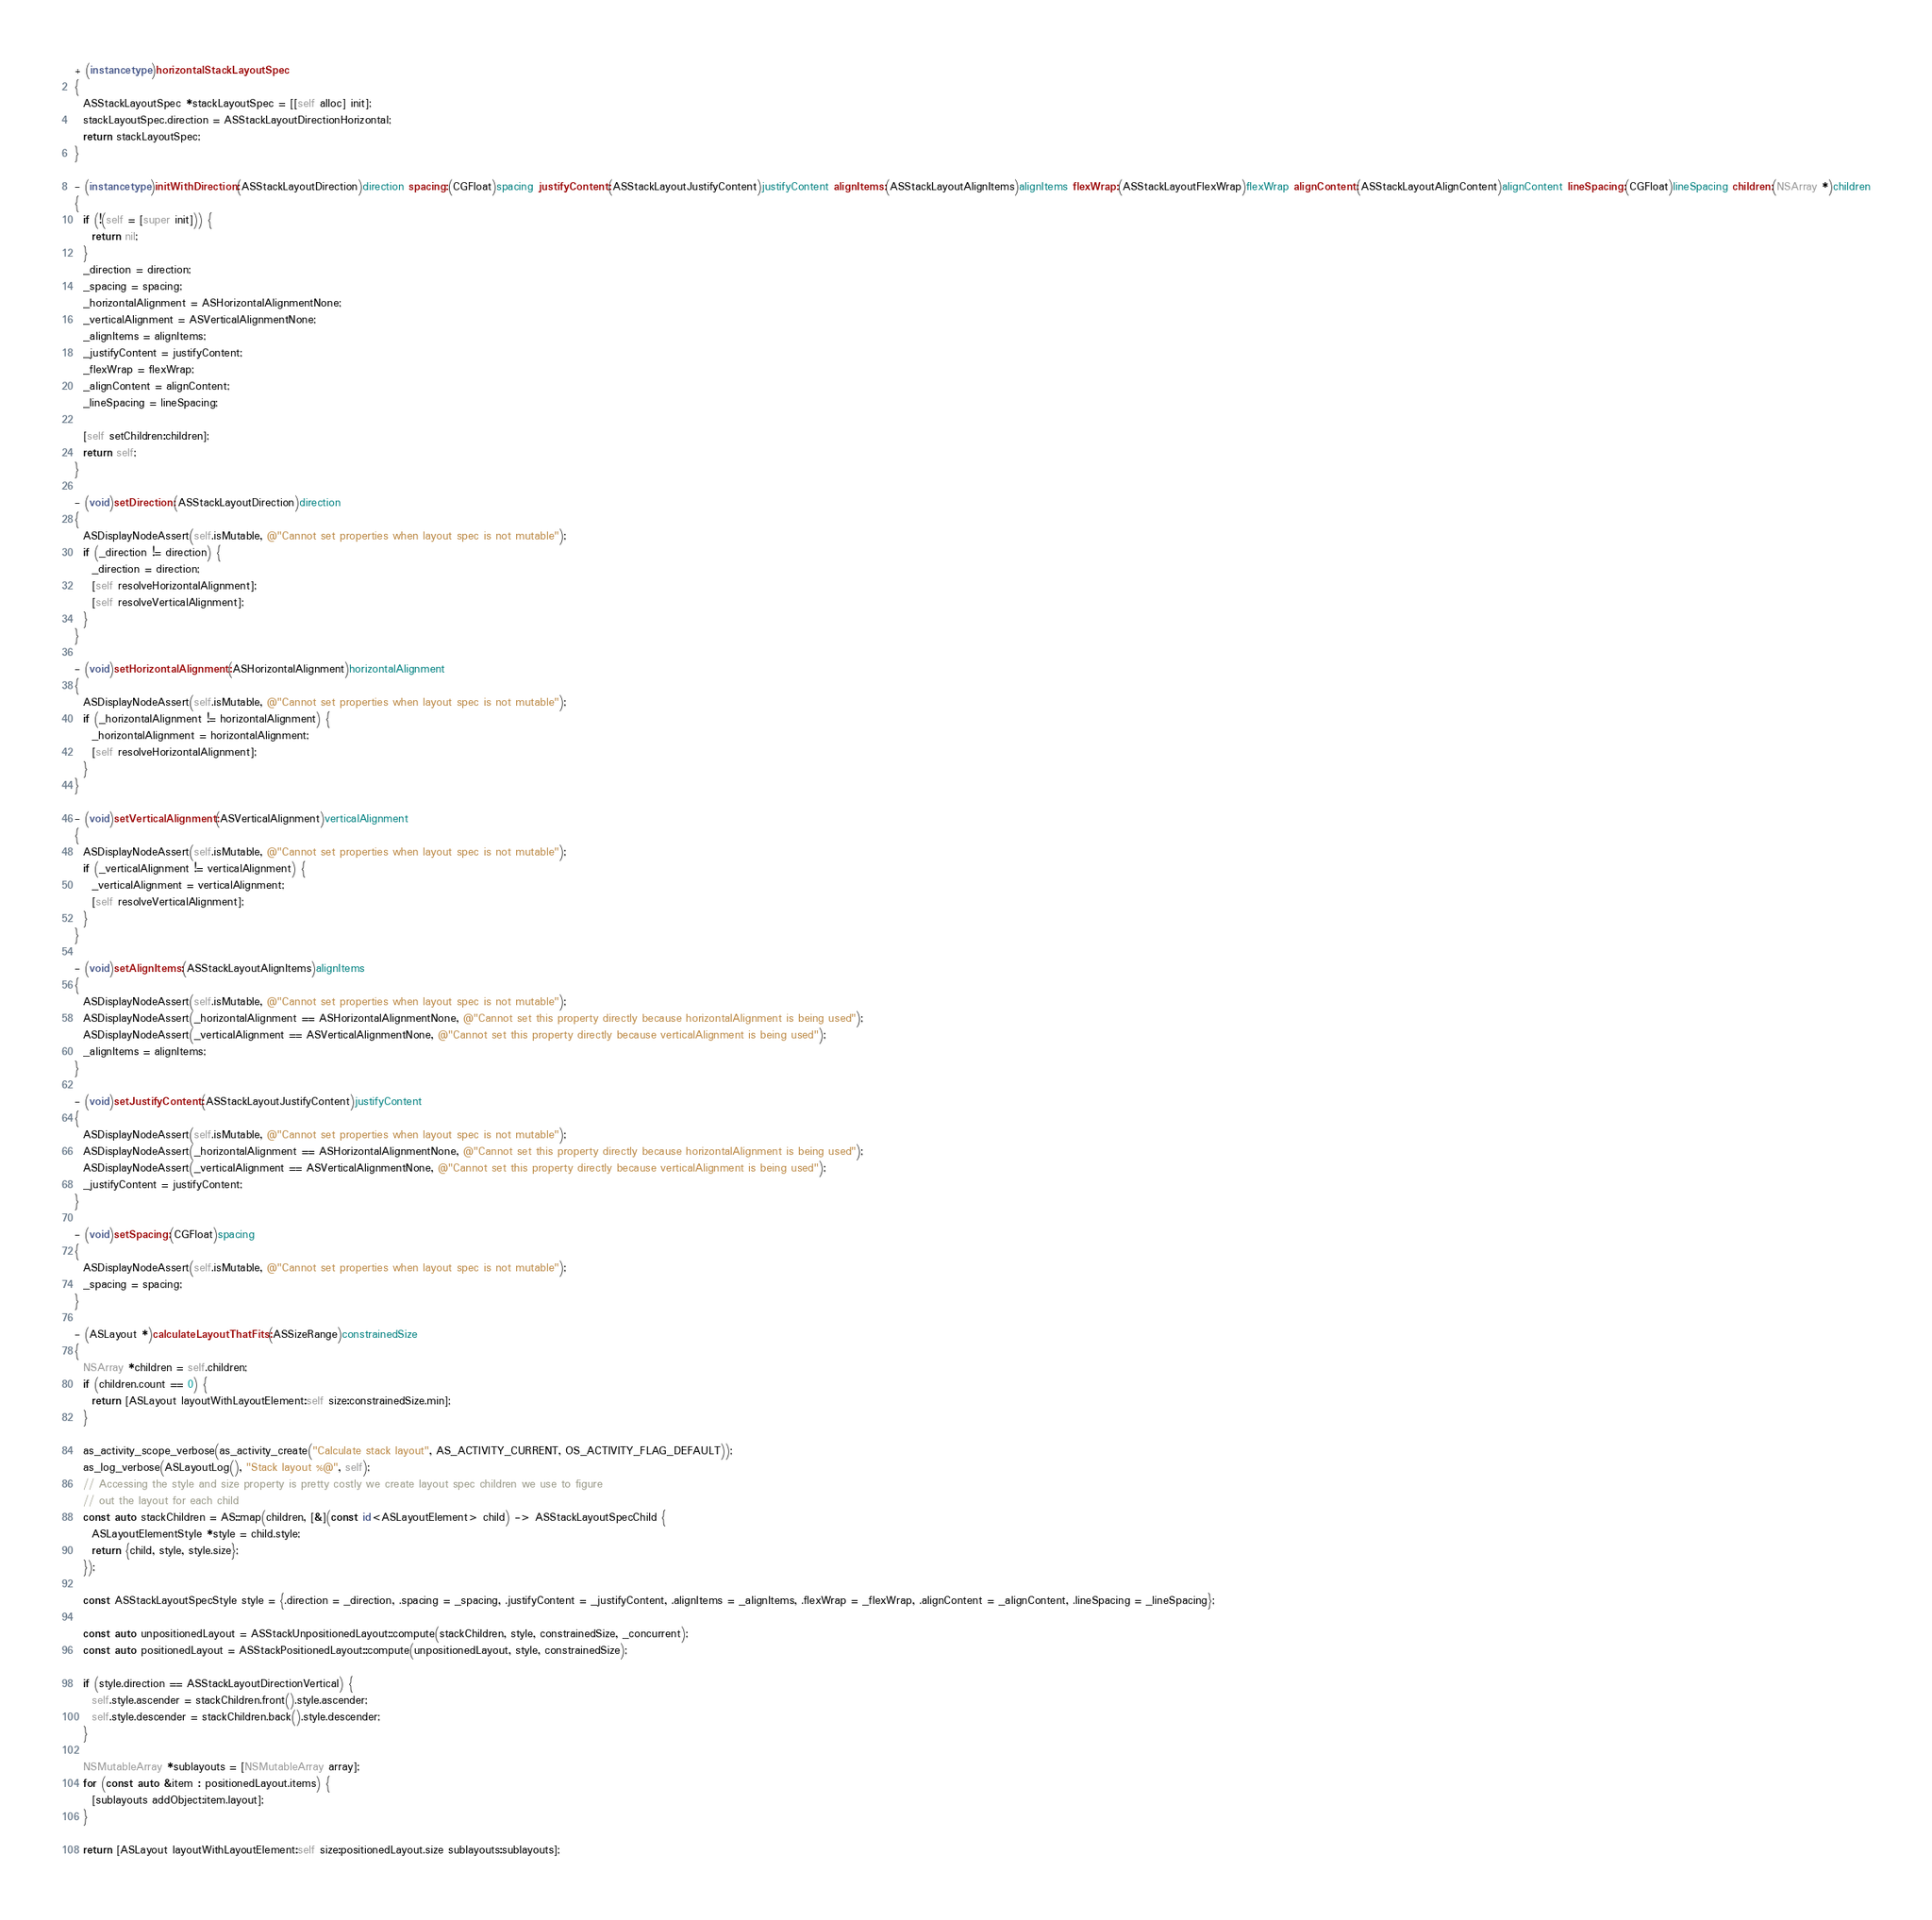<code> <loc_0><loc_0><loc_500><loc_500><_ObjectiveC_>+ (instancetype)horizontalStackLayoutSpec
{
  ASStackLayoutSpec *stackLayoutSpec = [[self alloc] init];
  stackLayoutSpec.direction = ASStackLayoutDirectionHorizontal;
  return stackLayoutSpec;
}

- (instancetype)initWithDirection:(ASStackLayoutDirection)direction spacing:(CGFloat)spacing justifyContent:(ASStackLayoutJustifyContent)justifyContent alignItems:(ASStackLayoutAlignItems)alignItems flexWrap:(ASStackLayoutFlexWrap)flexWrap alignContent:(ASStackLayoutAlignContent)alignContent lineSpacing:(CGFloat)lineSpacing children:(NSArray *)children
{
  if (!(self = [super init])) {
    return nil;
  }
  _direction = direction;
  _spacing = spacing;
  _horizontalAlignment = ASHorizontalAlignmentNone;
  _verticalAlignment = ASVerticalAlignmentNone;
  _alignItems = alignItems;
  _justifyContent = justifyContent;
  _flexWrap = flexWrap;
  _alignContent = alignContent;
  _lineSpacing = lineSpacing;
  
  [self setChildren:children];
  return self;
}

- (void)setDirection:(ASStackLayoutDirection)direction
{
  ASDisplayNodeAssert(self.isMutable, @"Cannot set properties when layout spec is not mutable");
  if (_direction != direction) {
    _direction = direction;
    [self resolveHorizontalAlignment];
    [self resolveVerticalAlignment];
  }
}

- (void)setHorizontalAlignment:(ASHorizontalAlignment)horizontalAlignment
{
  ASDisplayNodeAssert(self.isMutable, @"Cannot set properties when layout spec is not mutable");
  if (_horizontalAlignment != horizontalAlignment) {
    _horizontalAlignment = horizontalAlignment;
    [self resolveHorizontalAlignment];
  }
}

- (void)setVerticalAlignment:(ASVerticalAlignment)verticalAlignment
{
  ASDisplayNodeAssert(self.isMutable, @"Cannot set properties when layout spec is not mutable");
  if (_verticalAlignment != verticalAlignment) {
    _verticalAlignment = verticalAlignment;
    [self resolveVerticalAlignment];
  }
}

- (void)setAlignItems:(ASStackLayoutAlignItems)alignItems
{
  ASDisplayNodeAssert(self.isMutable, @"Cannot set properties when layout spec is not mutable");
  ASDisplayNodeAssert(_horizontalAlignment == ASHorizontalAlignmentNone, @"Cannot set this property directly because horizontalAlignment is being used");
  ASDisplayNodeAssert(_verticalAlignment == ASVerticalAlignmentNone, @"Cannot set this property directly because verticalAlignment is being used");
  _alignItems = alignItems;
}

- (void)setJustifyContent:(ASStackLayoutJustifyContent)justifyContent
{
  ASDisplayNodeAssert(self.isMutable, @"Cannot set properties when layout spec is not mutable");
  ASDisplayNodeAssert(_horizontalAlignment == ASHorizontalAlignmentNone, @"Cannot set this property directly because horizontalAlignment is being used");
  ASDisplayNodeAssert(_verticalAlignment == ASVerticalAlignmentNone, @"Cannot set this property directly because verticalAlignment is being used");
  _justifyContent = justifyContent;
}

- (void)setSpacing:(CGFloat)spacing
{
  ASDisplayNodeAssert(self.isMutable, @"Cannot set properties when layout spec is not mutable");
  _spacing = spacing;
}

- (ASLayout *)calculateLayoutThatFits:(ASSizeRange)constrainedSize
{
  NSArray *children = self.children;
  if (children.count == 0) {
    return [ASLayout layoutWithLayoutElement:self size:constrainedSize.min];
  }
 
  as_activity_scope_verbose(as_activity_create("Calculate stack layout", AS_ACTIVITY_CURRENT, OS_ACTIVITY_FLAG_DEFAULT));
  as_log_verbose(ASLayoutLog(), "Stack layout %@", self);
  // Accessing the style and size property is pretty costly we create layout spec children we use to figure
  // out the layout for each child
  const auto stackChildren = AS::map(children, [&](const id<ASLayoutElement> child) -> ASStackLayoutSpecChild {
    ASLayoutElementStyle *style = child.style;
    return {child, style, style.size};
  });
  
  const ASStackLayoutSpecStyle style = {.direction = _direction, .spacing = _spacing, .justifyContent = _justifyContent, .alignItems = _alignItems, .flexWrap = _flexWrap, .alignContent = _alignContent, .lineSpacing = _lineSpacing};
  
  const auto unpositionedLayout = ASStackUnpositionedLayout::compute(stackChildren, style, constrainedSize, _concurrent);
  const auto positionedLayout = ASStackPositionedLayout::compute(unpositionedLayout, style, constrainedSize);
  
  if (style.direction == ASStackLayoutDirectionVertical) {
    self.style.ascender = stackChildren.front().style.ascender;
    self.style.descender = stackChildren.back().style.descender;
  }
  
  NSMutableArray *sublayouts = [NSMutableArray array];
  for (const auto &item : positionedLayout.items) {
    [sublayouts addObject:item.layout];
  }

  return [ASLayout layoutWithLayoutElement:self size:positionedLayout.size sublayouts:sublayouts];</code> 